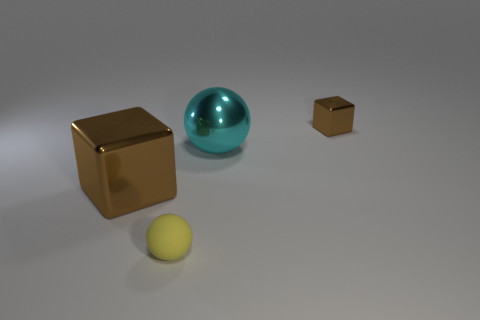What number of objects are to the right of the big brown cube and to the left of the metallic ball?
Your answer should be very brief. 1. How many rubber things are cyan things or red cubes?
Keep it short and to the point. 0. There is a tiny thing that is to the left of the block that is to the right of the large brown shiny object; what is it made of?
Offer a terse response. Rubber. There is a big thing that is the same color as the small metallic block; what shape is it?
Your answer should be compact. Cube. What is the shape of the other object that is the same size as the rubber object?
Keep it short and to the point. Cube. Is the number of small brown shiny things less than the number of big gray metallic blocks?
Give a very brief answer. No. There is a brown block on the left side of the tiny rubber object; are there any cubes that are left of it?
Offer a very short reply. No. There is a cyan thing that is made of the same material as the tiny cube; what is its shape?
Your response must be concise. Sphere. Are there any other things of the same color as the small matte object?
Your answer should be compact. No. What material is the yellow object that is the same shape as the large cyan shiny thing?
Ensure brevity in your answer.  Rubber. 